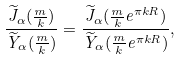Convert formula to latex. <formula><loc_0><loc_0><loc_500><loc_500>\frac { \widetilde { J } _ { \alpha } ( \frac { m } { k } ) } { \widetilde { Y } _ { \alpha } ( \frac { m } { k } ) } = \frac { \widetilde { J } _ { \alpha } ( \frac { m } { k } e ^ { \pi k R } ) } { \widetilde { Y } _ { \alpha } ( \frac { m } { k } e ^ { \pi k R } ) } ,</formula> 